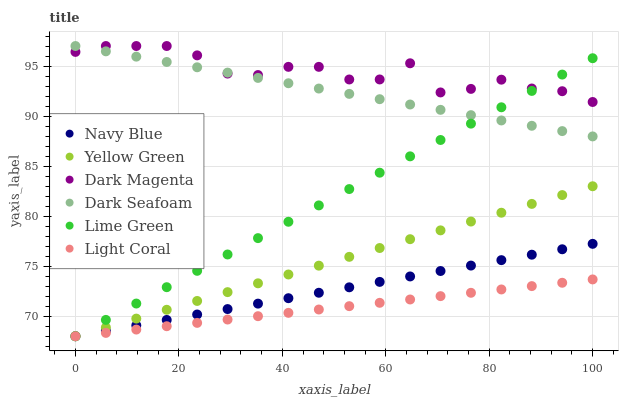Does Light Coral have the minimum area under the curve?
Answer yes or no. Yes. Does Dark Magenta have the maximum area under the curve?
Answer yes or no. Yes. Does Navy Blue have the minimum area under the curve?
Answer yes or no. No. Does Navy Blue have the maximum area under the curve?
Answer yes or no. No. Is Dark Seafoam the smoothest?
Answer yes or no. Yes. Is Dark Magenta the roughest?
Answer yes or no. Yes. Is Navy Blue the smoothest?
Answer yes or no. No. Is Navy Blue the roughest?
Answer yes or no. No. Does Yellow Green have the lowest value?
Answer yes or no. Yes. Does Dark Seafoam have the lowest value?
Answer yes or no. No. Does Dark Magenta have the highest value?
Answer yes or no. Yes. Does Navy Blue have the highest value?
Answer yes or no. No. Is Light Coral less than Dark Seafoam?
Answer yes or no. Yes. Is Dark Magenta greater than Light Coral?
Answer yes or no. Yes. Does Navy Blue intersect Light Coral?
Answer yes or no. Yes. Is Navy Blue less than Light Coral?
Answer yes or no. No. Is Navy Blue greater than Light Coral?
Answer yes or no. No. Does Light Coral intersect Dark Seafoam?
Answer yes or no. No. 